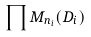Convert formula to latex. <formula><loc_0><loc_0><loc_500><loc_500>\prod M _ { n _ { i } } ( D _ { i } )</formula> 